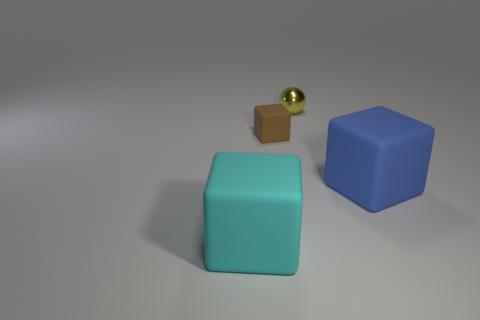Subtract all brown blocks. How many blocks are left? 2 Add 4 small gray shiny cubes. How many objects exist? 8 Subtract all balls. How many objects are left? 3 Subtract all yellow shiny objects. Subtract all large cyan things. How many objects are left? 2 Add 4 yellow spheres. How many yellow spheres are left? 5 Add 4 large brown cubes. How many large brown cubes exist? 4 Subtract 0 brown spheres. How many objects are left? 4 